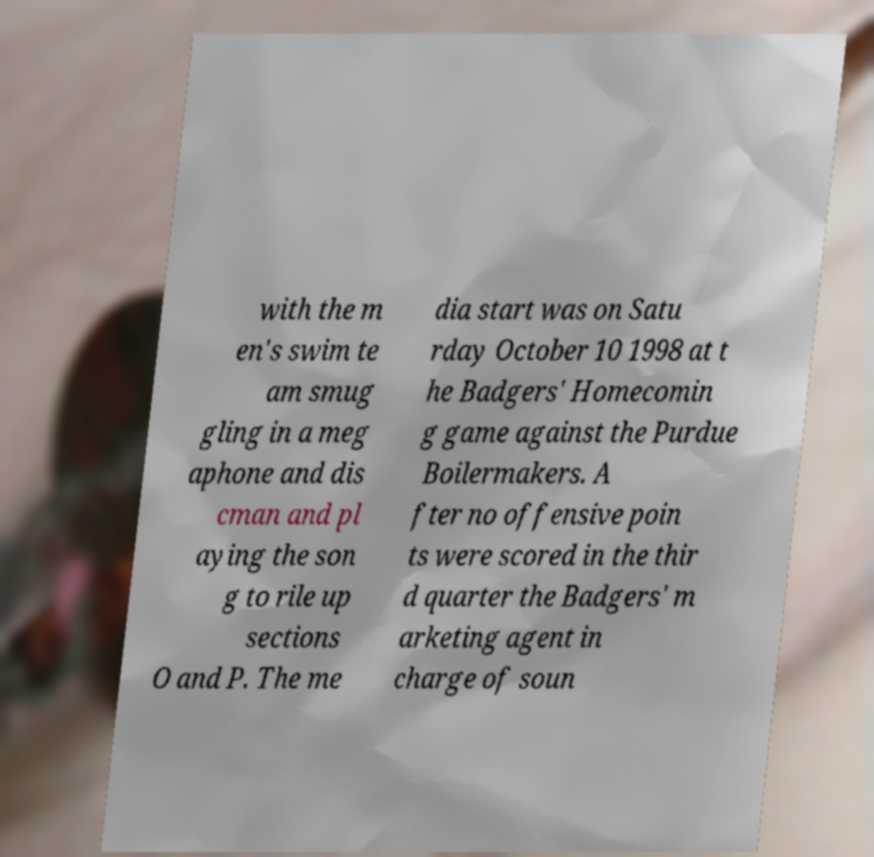For documentation purposes, I need the text within this image transcribed. Could you provide that? with the m en's swim te am smug gling in a meg aphone and dis cman and pl aying the son g to rile up sections O and P. The me dia start was on Satu rday October 10 1998 at t he Badgers' Homecomin g game against the Purdue Boilermakers. A fter no offensive poin ts were scored in the thir d quarter the Badgers' m arketing agent in charge of soun 